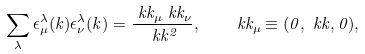<formula> <loc_0><loc_0><loc_500><loc_500>\sum _ { \lambda } \epsilon _ { \mu } ^ { \lambda } ( k ) \epsilon _ { \nu } ^ { \lambda } ( k ) = \frac { \ k k _ { \mu } \ k k _ { \nu } } { \ k k ^ { 2 } } , \quad \ k k _ { \mu } \equiv ( 0 , \ k k , 0 ) ,</formula> 